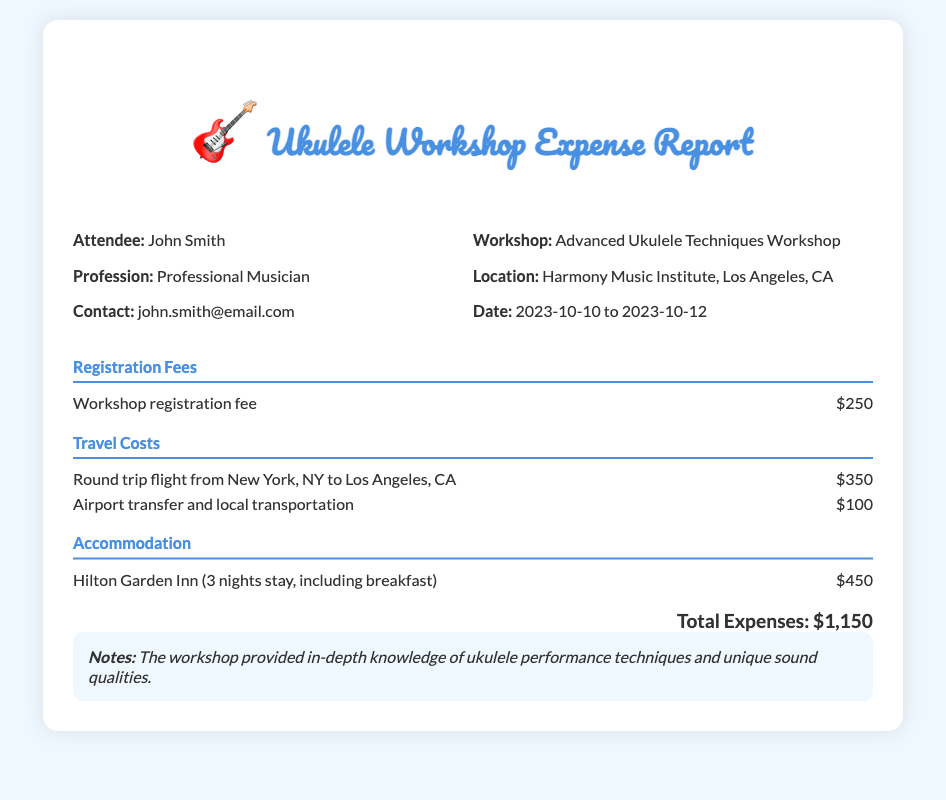What is the attendee's name? The document lists the attendee's name as John Smith.
Answer: John Smith What was the total amount spent on the workshop? The total expenses reported at the end of the document sum up to $1,150.
Answer: $1,150 Where was the workshop held? According to the document, the workshop took place at Harmony Music Institute, Los Angeles, CA.
Answer: Harmony Music Institute, Los Angeles, CA What are the travel costs listed in the report? The travel costs include a round trip flight of $350 and local transportation of $100, totaling $450.
Answer: $450 How many nights did the attendee stay in the hotel? The attendee stayed for three nights, as indicated in the accommodation section.
Answer: 3 nights What was the date range of the workshop? The workshop occurred from October 10 to October 12, 2023, as mentioned in the document.
Answer: 2023-10-10 to 2023-10-12 What type of transportation expense is included in the report? The report details expenses for a round trip flight and local transportation, indicating different modes of transport.
Answer: Round trip flight and local transportation What was the registration fee for the workshop? The document states that the workshop registration fee was $250.
Answer: $250 What hotel did the attendee stay at? The hotel mentioned in the report is Hilton Garden Inn.
Answer: Hilton Garden Inn 